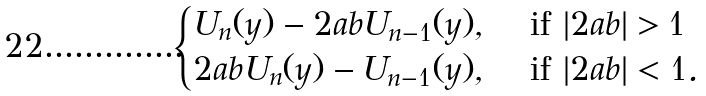<formula> <loc_0><loc_0><loc_500><loc_500>\begin{cases} U _ { n } ( y ) - 2 a b U _ { n - 1 } ( y ) , & \text { if } | 2 a b | > 1 \\ 2 a b U _ { n } ( y ) - U _ { n - 1 } ( y ) , & \text { if } | 2 a b | < 1 . \end{cases}</formula> 